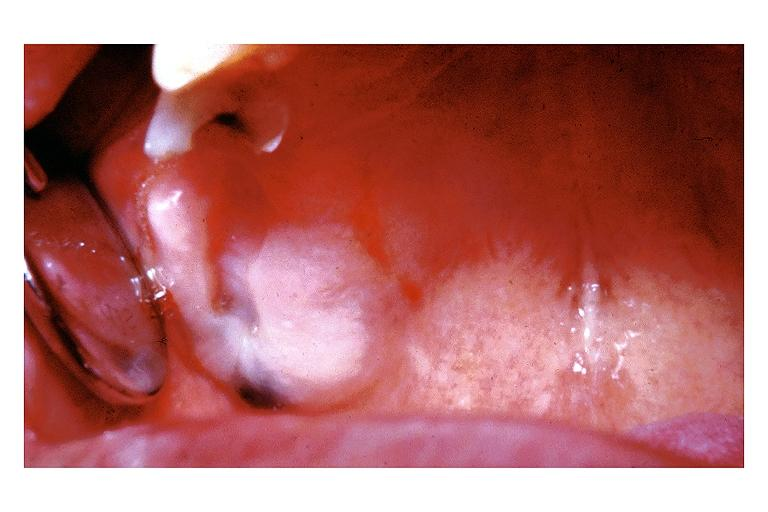does this image show amalgam tattoo?
Answer the question using a single word or phrase. Yes 